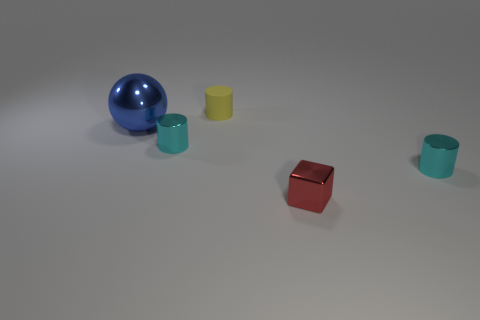Could these objects have a functional use? It's possible, although they appear more decorative or illustrative in this context. For instance, the cylinder shapes could be containers, and the cube could be a paperweight, but their use is not explicitly clear from the image alone. 